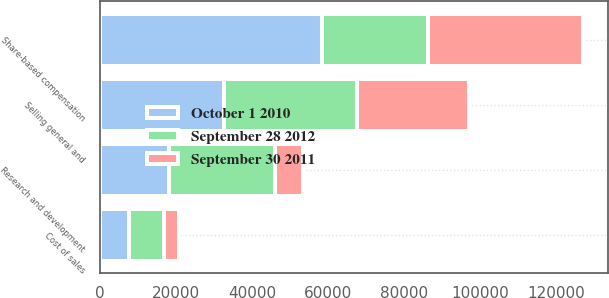Convert chart. <chart><loc_0><loc_0><loc_500><loc_500><stacked_bar_chart><ecel><fcel>Cost of sales<fcel>Research and development<fcel>Selling general and<fcel>Share-based compensation<nl><fcel>September 28 2012<fcel>9419<fcel>27982<fcel>34771<fcel>27982<nl><fcel>October 1 2010<fcel>7557<fcel>18100<fcel>32681<fcel>58338<nl><fcel>September 30 2011<fcel>3857<fcel>7419<fcel>29465<fcel>40741<nl></chart> 